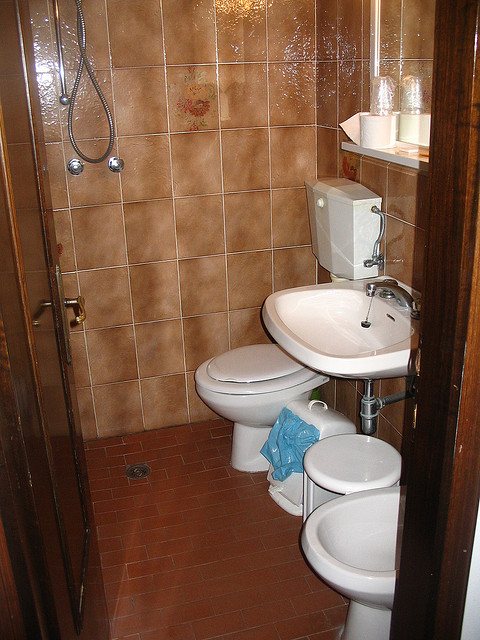How many toilets are in the picture? There is only one toilet visible in the image. The room also includes a bidet, which may resemble a toilet but is used for washing after using the toilet. 